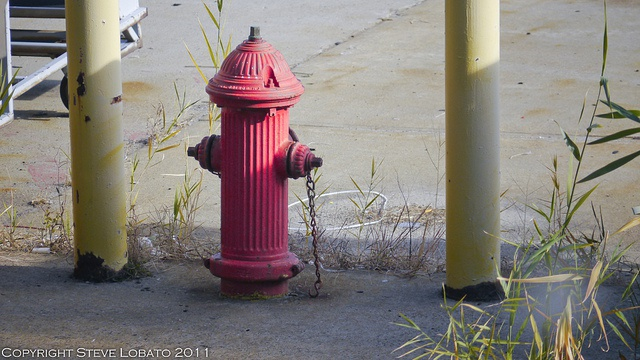Describe the objects in this image and their specific colors. I can see a fire hydrant in gray, purple, lightpink, and black tones in this image. 